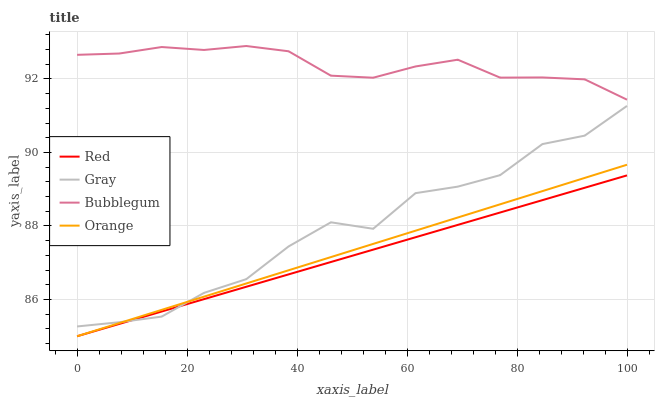Does Red have the minimum area under the curve?
Answer yes or no. Yes. Does Bubblegum have the maximum area under the curve?
Answer yes or no. Yes. Does Gray have the minimum area under the curve?
Answer yes or no. No. Does Gray have the maximum area under the curve?
Answer yes or no. No. Is Red the smoothest?
Answer yes or no. Yes. Is Gray the roughest?
Answer yes or no. Yes. Is Bubblegum the smoothest?
Answer yes or no. No. Is Bubblegum the roughest?
Answer yes or no. No. Does Gray have the lowest value?
Answer yes or no. No. Does Bubblegum have the highest value?
Answer yes or no. Yes. Does Gray have the highest value?
Answer yes or no. No. Is Red less than Bubblegum?
Answer yes or no. Yes. Is Bubblegum greater than Gray?
Answer yes or no. Yes. Does Gray intersect Red?
Answer yes or no. Yes. Is Gray less than Red?
Answer yes or no. No. Is Gray greater than Red?
Answer yes or no. No. Does Red intersect Bubblegum?
Answer yes or no. No. 